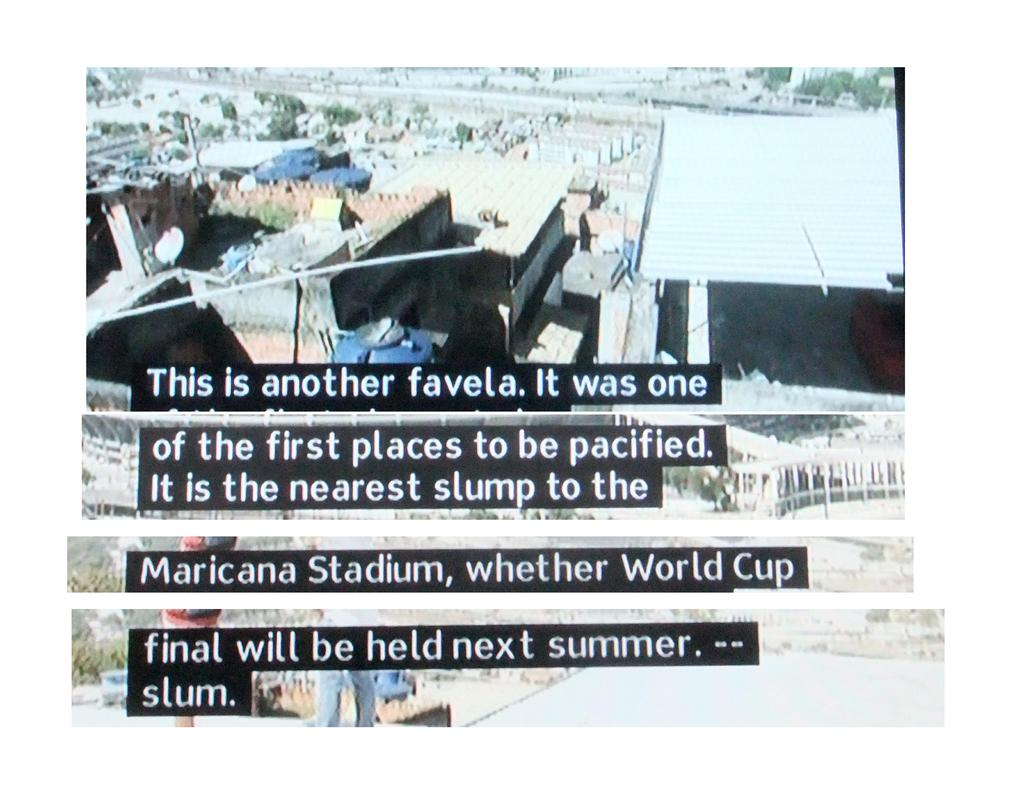What type of structures can be seen in the image? There are many buildings in the image. Is there any specific infrastructure visible in the image? Yes, there is a water tank in the image. Can you identify any text or writing in the image? Yes, there is text or writing on the image. What type of natural elements can be seen in the background of the image? There are trees in the background of the image. Are there any trees visible on a specific side of the image? Yes, there are trees on the right side of the image. Can you tell me how many goats are grazing near the water tank in the image? There are no goats present in the image; it features buildings, a water tank, and trees. Is there a prison visible in the image? There is no prison present in the image. 